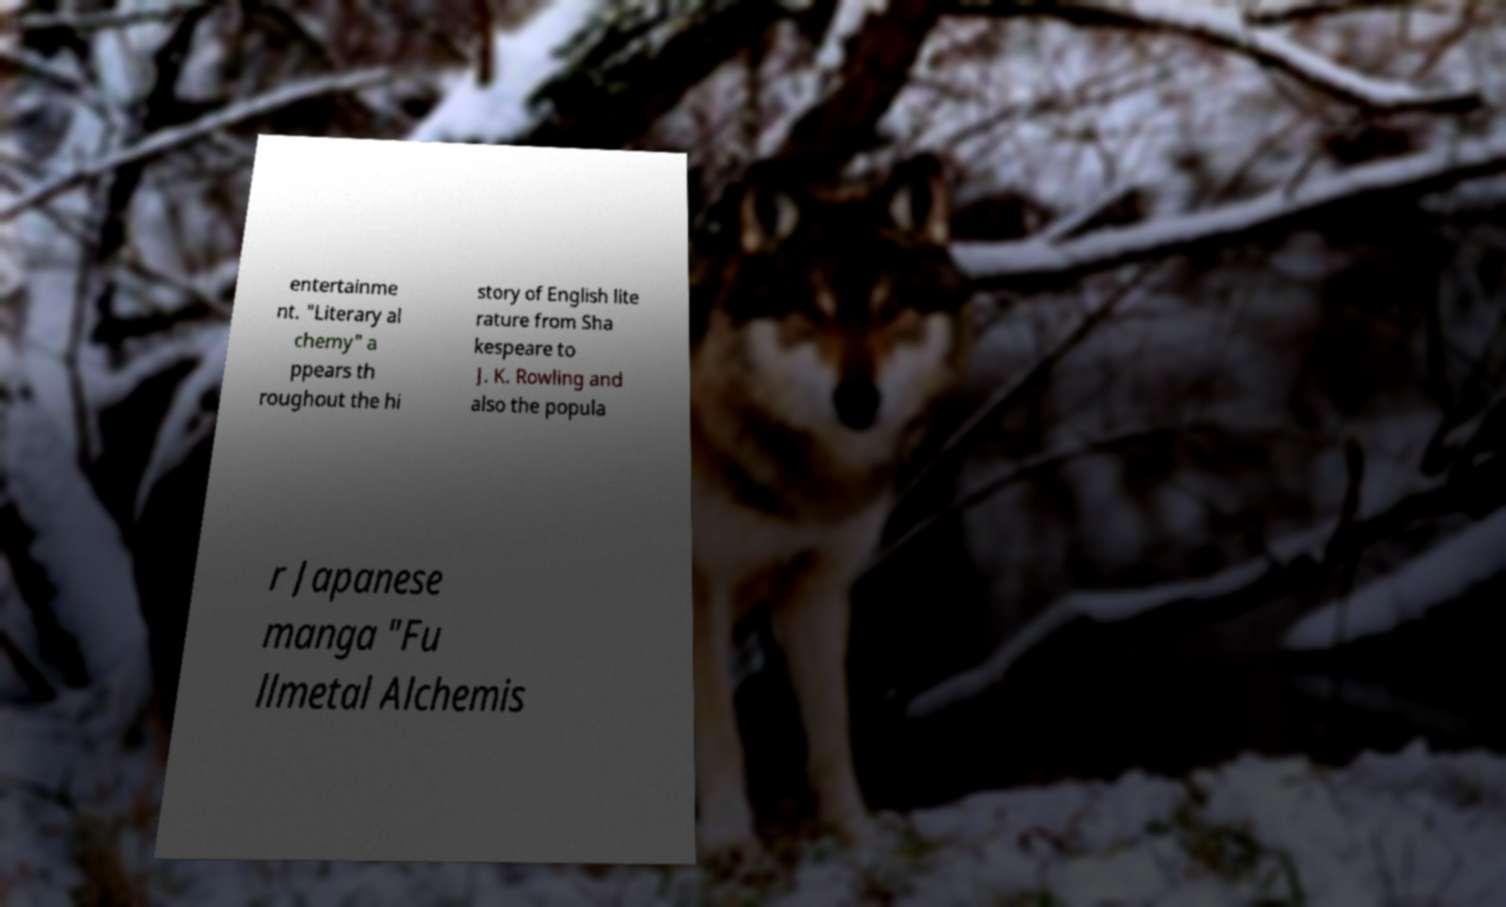Can you read and provide the text displayed in the image?This photo seems to have some interesting text. Can you extract and type it out for me? entertainme nt. "Literary al chemy" a ppears th roughout the hi story of English lite rature from Sha kespeare to J. K. Rowling and also the popula r Japanese manga "Fu llmetal Alchemis 